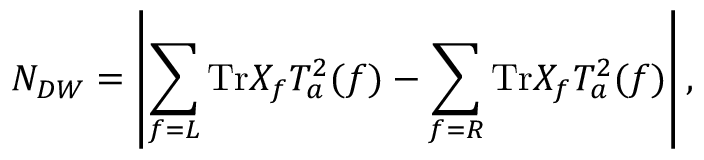<formula> <loc_0><loc_0><loc_500><loc_500>N _ { D W } = \left | \sum _ { f = L } T r X _ { f } T _ { a } ^ { 2 } ( f ) - \sum _ { f = R } T r X _ { f } T _ { a } ^ { 2 } ( f ) \right | ,</formula> 